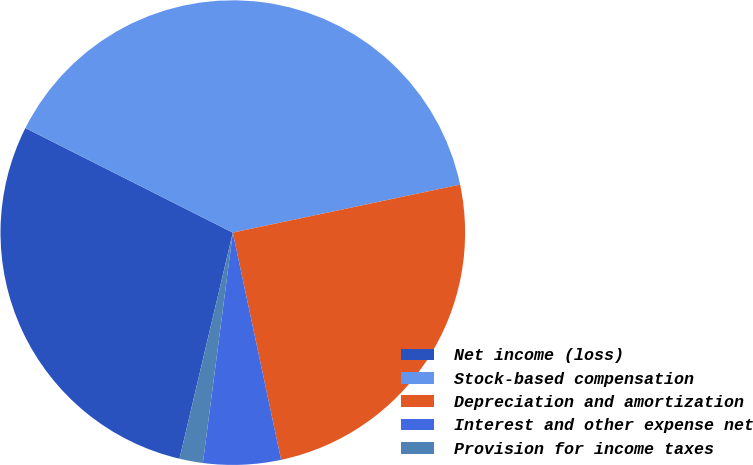Convert chart. <chart><loc_0><loc_0><loc_500><loc_500><pie_chart><fcel>Net income (loss)<fcel>Stock-based compensation<fcel>Depreciation and amortization<fcel>Interest and other expense net<fcel>Provision for income taxes<nl><fcel>28.75%<fcel>39.26%<fcel>24.98%<fcel>5.39%<fcel>1.63%<nl></chart> 